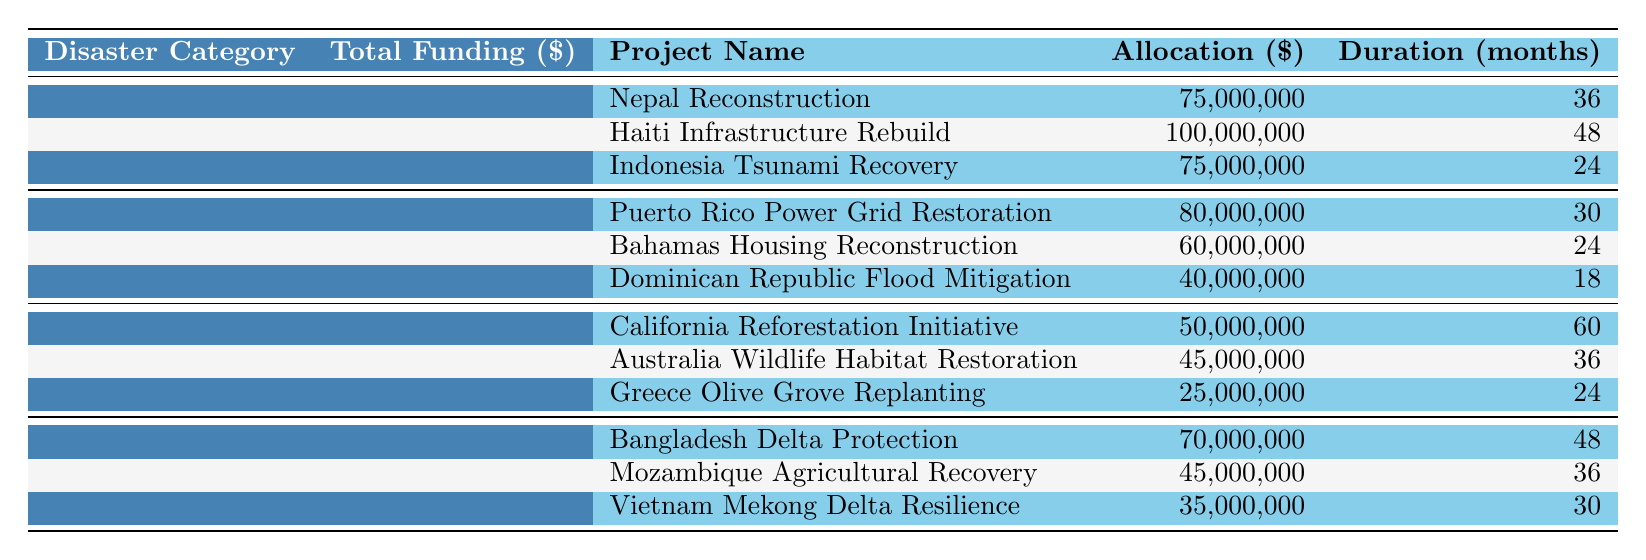What is the total funding allocated for earthquake projects? The total funding for earthquakes is explicitly listed in the table, which shows a value of 250,000,000 dollars.
Answer: 250,000,000 How much funding is allocated for the "Nepal Reconstruction" project? The allocation for the "Nepal Reconstruction" project is directly mentioned in the table as 75,000,000 dollars.
Answer: 75,000,000 What is the duration of the "Dominican Republic Flood Mitigation" project? The "Dominican Republic Flood Mitigation" project duration is provided in the table and is stated to be 18 months.
Answer: 18 Which disaster category received the least amount of total funding? By comparing the total funding values in the table, "Wildfires" received the least total funding of 120,000,000 dollars compared to others.
Answer: Wildfires What is the average allocation for the earthquake projects? To calculate the average, sum the allocations (75,000,000 + 100,000,000 + 75,000,000 = 250,000,000) and divide by the number of projects (3): 250,000,000 / 3 = 83,333,333.33.
Answer: 83,333,333.33 Is the funding for the "Puerto Rico Power Grid Restoration" greater than 70 million? The table states that the funding for this project is 80,000,000, which is indeed greater than 70 million.
Answer: Yes What is the total duration of all projects under the Floods category? To find the total duration, add all durations for the Floods category (48 + 36 + 30 = 114).
Answer: 114 How much more funding does the "Haiti Infrastructure Rebuild" project receive compared to the "Greece Olive Grove Replanting" project? The funding for "Haiti Infrastructure Rebuild" is 100,000,000, and "Greece Olive Grove Replanting" is 25,000,000. The difference is 100,000,000 - 25,000,000 = 75,000,000.
Answer: 75,000,000 How many total months of project duration are allocated for the Hurricanes category? The total duration for Hurricanes projects can be calculated by summing them: 30 + 24 + 18 = 72 months.
Answer: 72 Which project has the longest duration among all listed projects? The project with the longest duration is the "California Reforestation Initiative," with a duration of 60 months, as seen in the table.
Answer: California Reforestation Initiative 